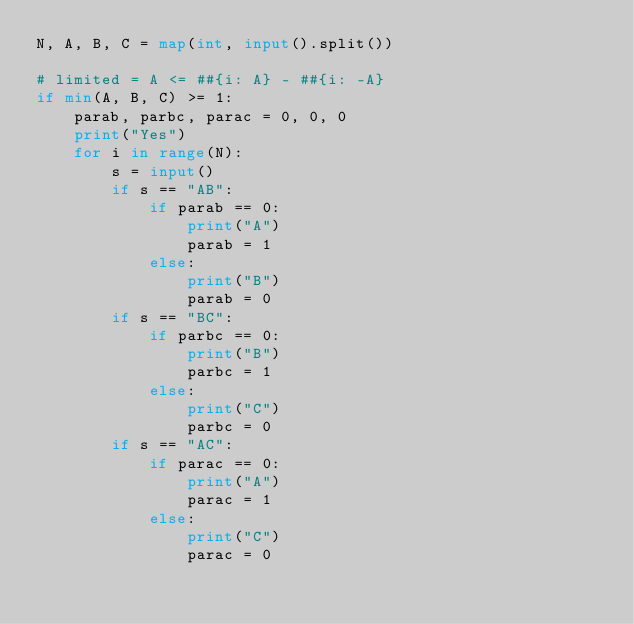Convert code to text. <code><loc_0><loc_0><loc_500><loc_500><_Python_>N, A, B, C = map(int, input().split())

# limited = A <= ##{i: A} - ##{i: -A}
if min(A, B, C) >= 1:
    parab, parbc, parac = 0, 0, 0
    print("Yes")
    for i in range(N):
        s = input()
        if s == "AB":
            if parab == 0:
                print("A")
                parab = 1
            else:
                print("B")
                parab = 0
        if s == "BC":
            if parbc == 0:
                print("B")
                parbc = 1
            else:
                print("C")
                parbc = 0
        if s == "AC":
            if parac == 0:
                print("A")
                parac = 1
            else:
                print("C")
                parac = 0
</code> 